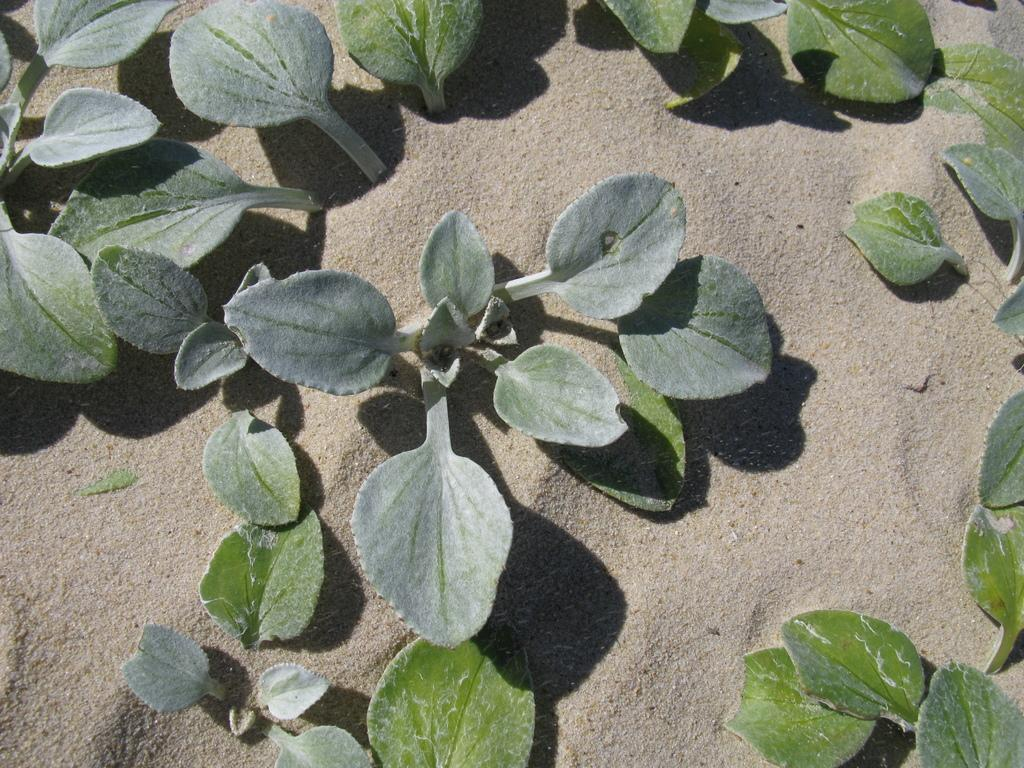What type of plants are visible in the image? There are plants in the sand in the image. What direction are the plants facing in the image? The provided facts do not specify the direction the plants are facing, so it cannot be determined from the image. 